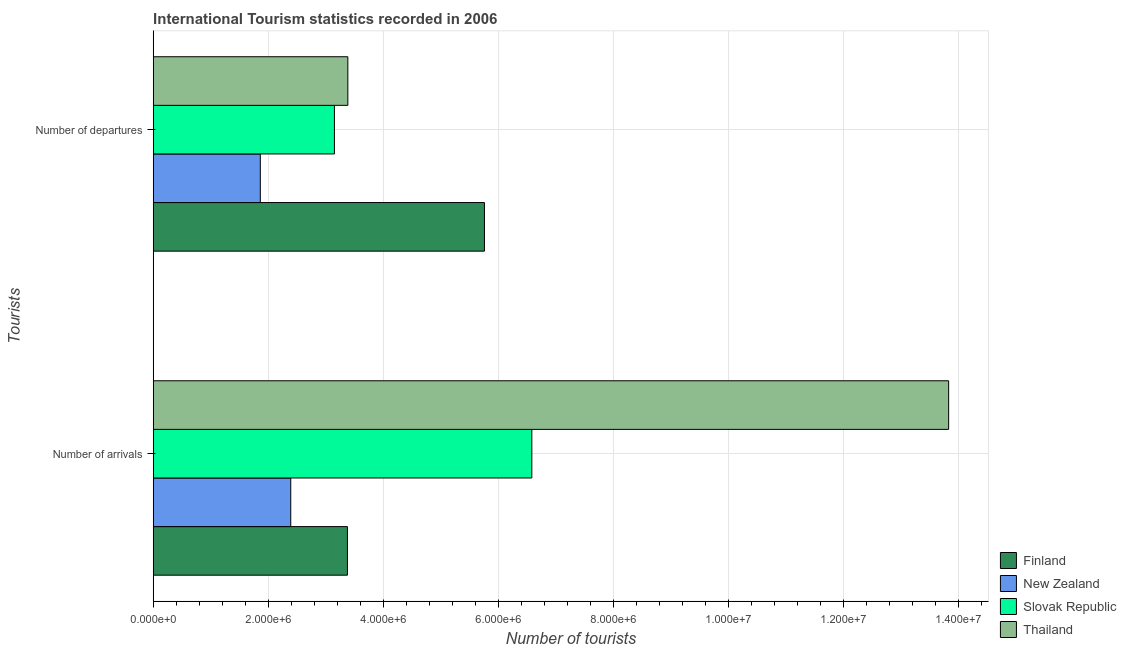How many different coloured bars are there?
Provide a succinct answer. 4. Are the number of bars per tick equal to the number of legend labels?
Offer a very short reply. Yes. How many bars are there on the 2nd tick from the top?
Give a very brief answer. 4. What is the label of the 1st group of bars from the top?
Give a very brief answer. Number of departures. What is the number of tourist arrivals in Slovak Republic?
Provide a short and direct response. 6.58e+06. Across all countries, what is the maximum number of tourist arrivals?
Keep it short and to the point. 1.38e+07. Across all countries, what is the minimum number of tourist arrivals?
Keep it short and to the point. 2.39e+06. In which country was the number of tourist departures minimum?
Your answer should be very brief. New Zealand. What is the total number of tourist arrivals in the graph?
Your response must be concise. 2.62e+07. What is the difference between the number of tourist arrivals in Finland and that in New Zealand?
Your response must be concise. 9.85e+05. What is the difference between the number of tourist arrivals in Finland and the number of tourist departures in Thailand?
Provide a succinct answer. -7000. What is the average number of tourist departures per country?
Your answer should be very brief. 3.54e+06. What is the difference between the number of tourist arrivals and number of tourist departures in Thailand?
Offer a terse response. 1.04e+07. In how many countries, is the number of tourist arrivals greater than 9600000 ?
Provide a short and direct response. 1. What is the ratio of the number of tourist departures in Thailand to that in Finland?
Ensure brevity in your answer.  0.59. What does the 4th bar from the bottom in Number of arrivals represents?
Offer a terse response. Thailand. Are all the bars in the graph horizontal?
Your answer should be compact. Yes. What is the difference between two consecutive major ticks on the X-axis?
Provide a succinct answer. 2.00e+06. Does the graph contain grids?
Make the answer very short. Yes. How are the legend labels stacked?
Keep it short and to the point. Vertical. What is the title of the graph?
Provide a succinct answer. International Tourism statistics recorded in 2006. Does "Bahamas" appear as one of the legend labels in the graph?
Make the answer very short. No. What is the label or title of the X-axis?
Your answer should be very brief. Number of tourists. What is the label or title of the Y-axis?
Make the answer very short. Tourists. What is the Number of tourists in Finland in Number of arrivals?
Your answer should be compact. 3.38e+06. What is the Number of tourists in New Zealand in Number of arrivals?
Your answer should be very brief. 2.39e+06. What is the Number of tourists of Slovak Republic in Number of arrivals?
Your answer should be compact. 6.58e+06. What is the Number of tourists of Thailand in Number of arrivals?
Ensure brevity in your answer.  1.38e+07. What is the Number of tourists of Finland in Number of departures?
Keep it short and to the point. 5.76e+06. What is the Number of tourists of New Zealand in Number of departures?
Your answer should be very brief. 1.86e+06. What is the Number of tourists in Slovak Republic in Number of departures?
Make the answer very short. 3.15e+06. What is the Number of tourists of Thailand in Number of departures?
Your answer should be compact. 3.38e+06. Across all Tourists, what is the maximum Number of tourists of Finland?
Your answer should be compact. 5.76e+06. Across all Tourists, what is the maximum Number of tourists in New Zealand?
Offer a terse response. 2.39e+06. Across all Tourists, what is the maximum Number of tourists in Slovak Republic?
Your answer should be very brief. 6.58e+06. Across all Tourists, what is the maximum Number of tourists in Thailand?
Provide a short and direct response. 1.38e+07. Across all Tourists, what is the minimum Number of tourists of Finland?
Ensure brevity in your answer.  3.38e+06. Across all Tourists, what is the minimum Number of tourists of New Zealand?
Your answer should be compact. 1.86e+06. Across all Tourists, what is the minimum Number of tourists of Slovak Republic?
Your answer should be very brief. 3.15e+06. Across all Tourists, what is the minimum Number of tourists of Thailand?
Provide a short and direct response. 3.38e+06. What is the total Number of tourists of Finland in the graph?
Offer a terse response. 9.13e+06. What is the total Number of tourists in New Zealand in the graph?
Provide a short and direct response. 4.25e+06. What is the total Number of tourists in Slovak Republic in the graph?
Your answer should be compact. 9.73e+06. What is the total Number of tourists in Thailand in the graph?
Make the answer very short. 1.72e+07. What is the difference between the Number of tourists of Finland in Number of arrivals and that in Number of departures?
Your answer should be very brief. -2.38e+06. What is the difference between the Number of tourists of New Zealand in Number of arrivals and that in Number of departures?
Your response must be concise. 5.29e+05. What is the difference between the Number of tourists in Slovak Republic in Number of arrivals and that in Number of departures?
Keep it short and to the point. 3.43e+06. What is the difference between the Number of tourists of Thailand in Number of arrivals and that in Number of departures?
Offer a terse response. 1.04e+07. What is the difference between the Number of tourists of Finland in Number of arrivals and the Number of tourists of New Zealand in Number of departures?
Keep it short and to the point. 1.51e+06. What is the difference between the Number of tourists of Finland in Number of arrivals and the Number of tourists of Slovak Republic in Number of departures?
Give a very brief answer. 2.26e+05. What is the difference between the Number of tourists in Finland in Number of arrivals and the Number of tourists in Thailand in Number of departures?
Offer a terse response. -7000. What is the difference between the Number of tourists of New Zealand in Number of arrivals and the Number of tourists of Slovak Republic in Number of departures?
Make the answer very short. -7.59e+05. What is the difference between the Number of tourists of New Zealand in Number of arrivals and the Number of tourists of Thailand in Number of departures?
Offer a very short reply. -9.92e+05. What is the difference between the Number of tourists of Slovak Republic in Number of arrivals and the Number of tourists of Thailand in Number of departures?
Your answer should be very brief. 3.20e+06. What is the average Number of tourists of Finland per Tourists?
Give a very brief answer. 4.57e+06. What is the average Number of tourists in New Zealand per Tourists?
Provide a short and direct response. 2.13e+06. What is the average Number of tourists of Slovak Republic per Tourists?
Provide a short and direct response. 4.86e+06. What is the average Number of tourists of Thailand per Tourists?
Offer a very short reply. 8.60e+06. What is the difference between the Number of tourists of Finland and Number of tourists of New Zealand in Number of arrivals?
Provide a short and direct response. 9.85e+05. What is the difference between the Number of tourists in Finland and Number of tourists in Slovak Republic in Number of arrivals?
Keep it short and to the point. -3.20e+06. What is the difference between the Number of tourists of Finland and Number of tourists of Thailand in Number of arrivals?
Provide a short and direct response. -1.04e+07. What is the difference between the Number of tourists of New Zealand and Number of tourists of Slovak Republic in Number of arrivals?
Offer a terse response. -4.19e+06. What is the difference between the Number of tourists in New Zealand and Number of tourists in Thailand in Number of arrivals?
Ensure brevity in your answer.  -1.14e+07. What is the difference between the Number of tourists in Slovak Republic and Number of tourists in Thailand in Number of arrivals?
Your answer should be very brief. -7.24e+06. What is the difference between the Number of tourists in Finland and Number of tourists in New Zealand in Number of departures?
Provide a short and direct response. 3.90e+06. What is the difference between the Number of tourists in Finland and Number of tourists in Slovak Republic in Number of departures?
Offer a terse response. 2.61e+06. What is the difference between the Number of tourists in Finland and Number of tourists in Thailand in Number of departures?
Provide a succinct answer. 2.37e+06. What is the difference between the Number of tourists of New Zealand and Number of tourists of Slovak Republic in Number of departures?
Offer a very short reply. -1.29e+06. What is the difference between the Number of tourists in New Zealand and Number of tourists in Thailand in Number of departures?
Ensure brevity in your answer.  -1.52e+06. What is the difference between the Number of tourists in Slovak Republic and Number of tourists in Thailand in Number of departures?
Keep it short and to the point. -2.33e+05. What is the ratio of the Number of tourists of Finland in Number of arrivals to that in Number of departures?
Provide a succinct answer. 0.59. What is the ratio of the Number of tourists in New Zealand in Number of arrivals to that in Number of departures?
Make the answer very short. 1.28. What is the ratio of the Number of tourists of Slovak Republic in Number of arrivals to that in Number of departures?
Your answer should be compact. 2.09. What is the ratio of the Number of tourists in Thailand in Number of arrivals to that in Number of departures?
Provide a short and direct response. 4.09. What is the difference between the highest and the second highest Number of tourists in Finland?
Your response must be concise. 2.38e+06. What is the difference between the highest and the second highest Number of tourists in New Zealand?
Offer a terse response. 5.29e+05. What is the difference between the highest and the second highest Number of tourists in Slovak Republic?
Make the answer very short. 3.43e+06. What is the difference between the highest and the second highest Number of tourists in Thailand?
Offer a very short reply. 1.04e+07. What is the difference between the highest and the lowest Number of tourists in Finland?
Your response must be concise. 2.38e+06. What is the difference between the highest and the lowest Number of tourists of New Zealand?
Your response must be concise. 5.29e+05. What is the difference between the highest and the lowest Number of tourists of Slovak Republic?
Your answer should be compact. 3.43e+06. What is the difference between the highest and the lowest Number of tourists of Thailand?
Your answer should be very brief. 1.04e+07. 